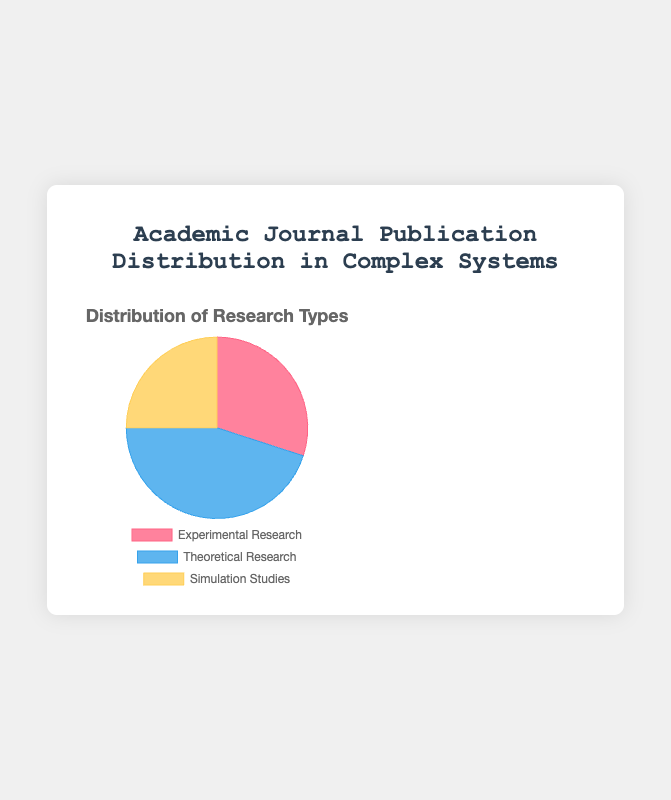What percentage of journal publications is in theoretical research? The theoretical research portion is visually represented and labeled in the pie chart, showing 45%.
Answer: 45% How does the number of simulation studies compare to experimental research? The pie chart shows that simulation studies account for 25%, while experimental research accounts for 30%. Thus, simulation studies are 5% less than experimental research.
Answer: 5% less Which category has the smallest share of publications? By observing the pie chart and the labeled percentages, "Simulation Studies" has the smallest share at 25%.
Answer: Simulation Studies What is the total percentage of non-experimental research publications? Adding the percentages for Theoretical Research (45%) and Simulation Studies (25%) gives 45% + 25% = 70%.
Answer: 70% If the total number of publications is 200, how many publications are theoretical research? Given that theoretical research makes up 45% of the total, we calculate as follows: 0.45 * 200 = 90 publications.
Answer: 90 What is the ratio of experimental research to simulation studies? The pie chart shows 30% for Experimental Research and 25% for Simulation Studies. The ratio is 30:25, which simplifies to 6:5.
Answer: 6:5 Which two categories together provide more than half of the total publications? Adding Experimental Research (30%) and Theoretical Research (45%) gives 75%, more than half of the total.
Answer: Experimental Research and Theoretical Research What would be the change in percentage share if experimental research publications increased to 40%? If Experimental Research rises to 40%, the total is now 40 + 45 + 25 = 110%. Rescaling to total 100%, Experimental Research would be 40/110*100 ≈ 36.36%, Theoretical Research 45/110*100 ≈ 40.91%, and Simulation Studies 25/110*100 ≈ 22.73%.
Answer: Experimental Research ≈ 36.36%, Theoretical Research ≈ 40.91%, Simulation Studies ≈ 22.73% What color in the pie chart represents the category with the highest publication share? The highest publication share is in Theoretical Research, which is represented by the color blue in the pie chart.
Answer: Blue Identify two categories whose combined percentage is equivalent to the largest category's percentage. The largest category is Theoretical Research at 45%. Adding Experimental Research (30%) and Simulation Studies (25%) gives 30% + 25% = 55%, which is greater. Thus, no exact combination equals 45%.
Answer: None 